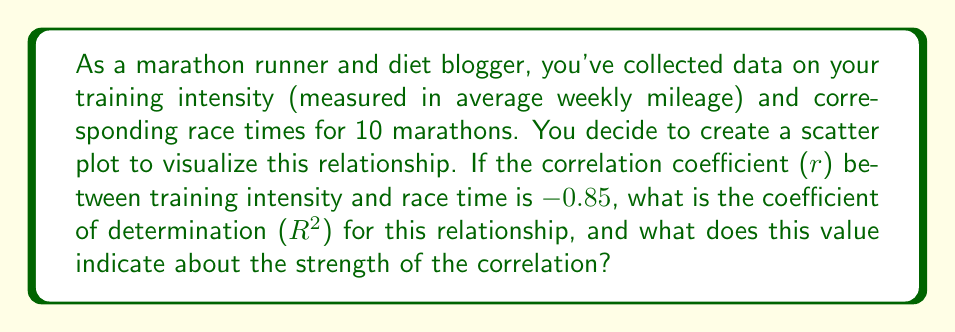Solve this math problem. To solve this problem, we need to understand the relationship between the correlation coefficient (r) and the coefficient of determination ($R^2$).

1. The correlation coefficient (r) measures the strength and direction of a linear relationship between two variables. It ranges from -1 to 1, where:
   - -1 indicates a perfect negative linear relationship
   - 0 indicates no linear relationship
   - 1 indicates a perfect positive linear relationship

2. In this case, r = -0.85, which indicates a strong negative linear relationship between training intensity and race time. This makes sense intuitively, as higher training intensity (more weekly mileage) generally leads to faster race times (lower times).

3. The coefficient of determination ($R^2$) is the square of the correlation coefficient. It represents the proportion of the variance in the dependent variable (race time) that is predictable from the independent variable (training intensity).

4. To calculate $R^2$, we simply square the correlation coefficient:

   $$R^2 = r^2 = (-0.85)^2 = 0.7225$$

5. The $R^2$ value of 0.7225 can be interpreted as follows:
   - Approximately 72.25% of the variance in race times can be explained by the variation in training intensity.
   - This indicates a strong relationship between training intensity and race performance.
   - The remaining 27.75% of variance in race times is due to other factors not accounted for in this model (e.g., diet, weather conditions, course difficulty).

6. In the context of your blog and personal journey, this $R^2$ value suggests that your training intensity (weekly mileage) has been a significant factor in your marathon performance, but there's still room for other factors (possibly including your various diets) to influence your race times.
Answer: $R^2 = 0.7225$ or $72.25\%$. This indicates a strong correlation between training intensity and race times, with about 72.25% of the variance in race times explained by training intensity. 